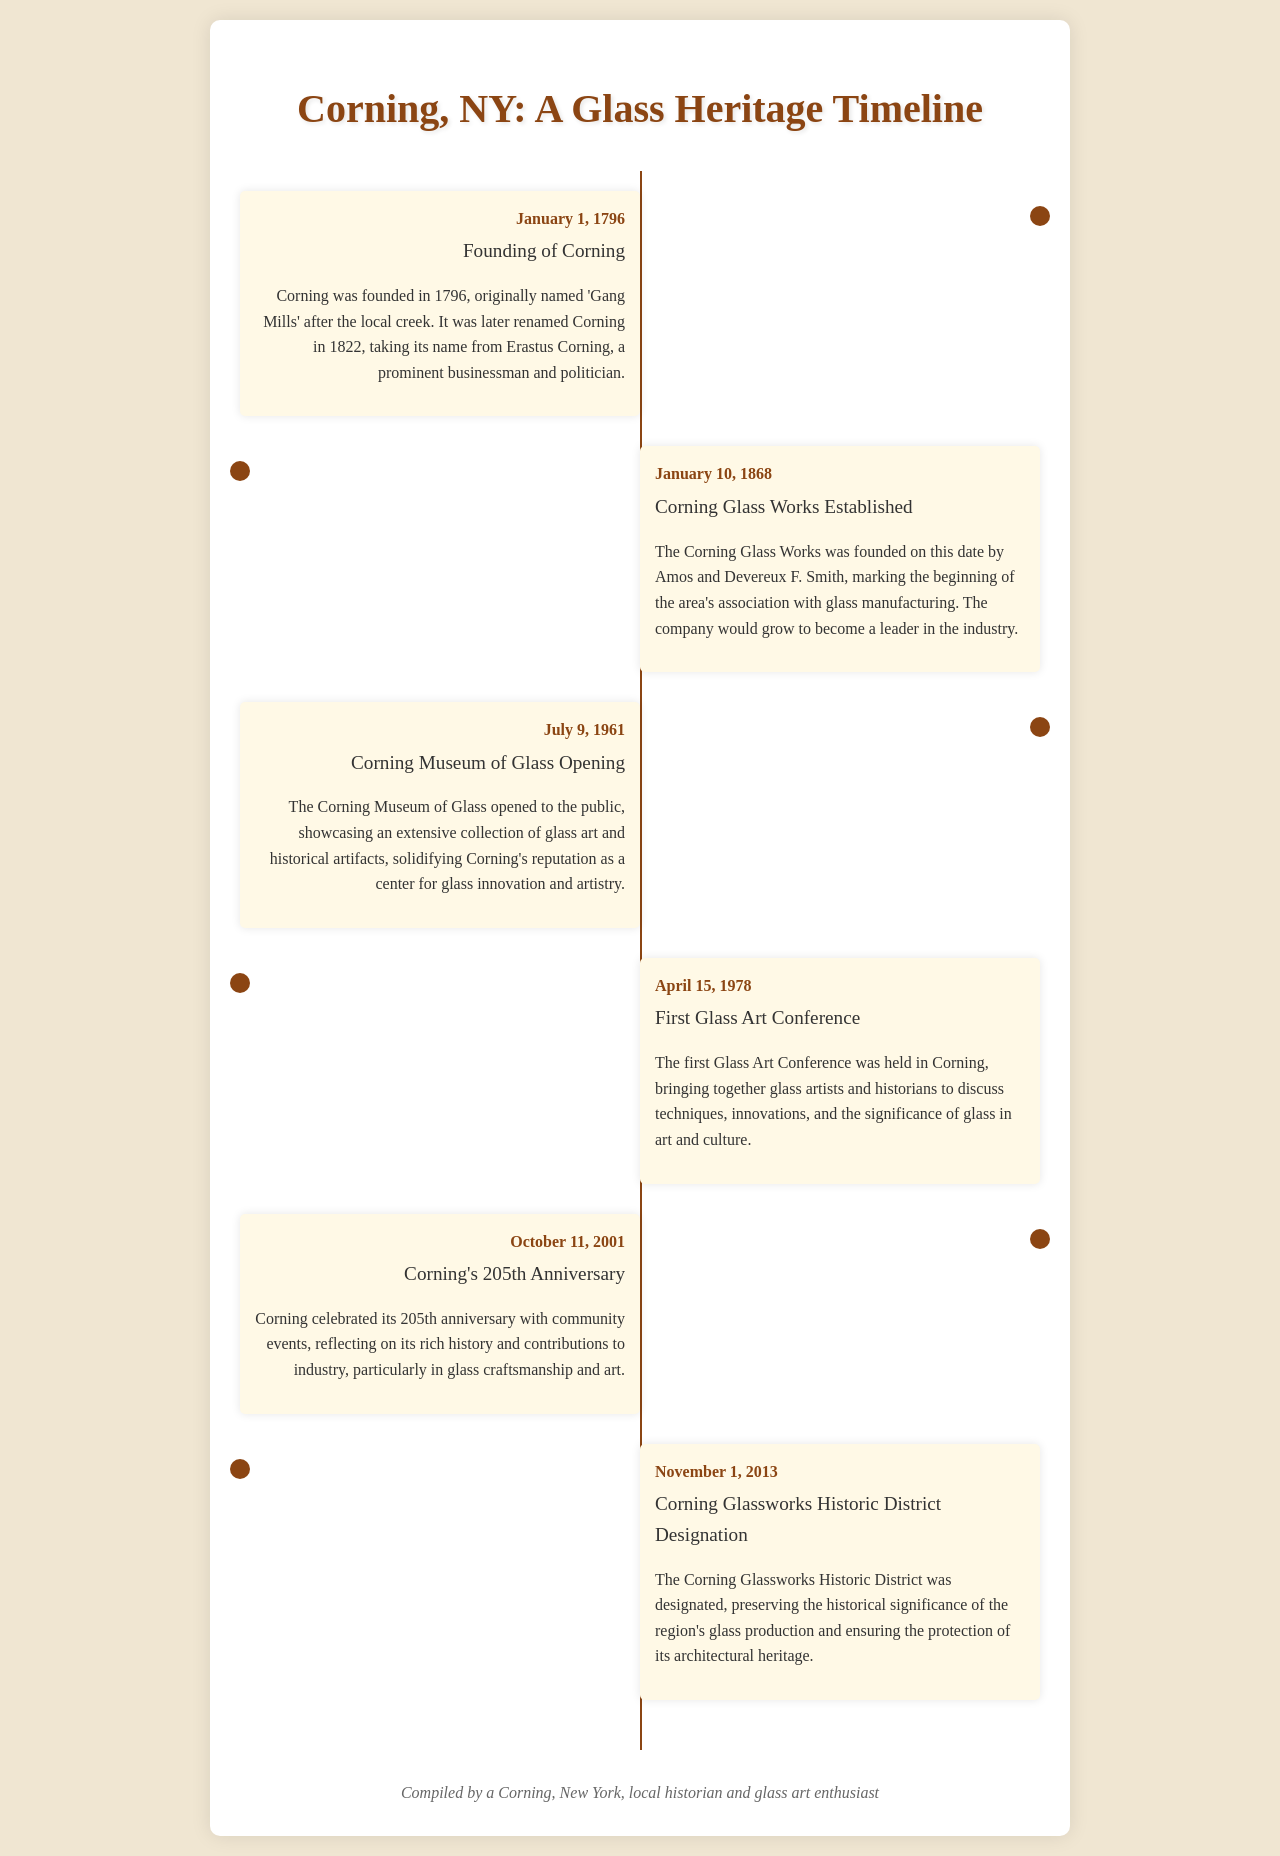What year was Corning founded? The document states that Corning was founded on January 1, 1796.
Answer: 1796 Who established Corning Glass Works? The text mentions that Corning Glass Works was founded by Amos and Devereux F. Smith.
Answer: Amos and Devereux F. Smith When did the Corning Museum of Glass open? According to the document, the Corning Museum of Glass opened on July 9, 1961.
Answer: July 9, 1961 What significant event occurred on April 15, 1978? The document notes that the first Glass Art Conference was held on this date in Corning.
Answer: First Glass Art Conference What anniversary did Corning celebrate on October 11, 2001? The text indicates that Corning celebrated its 205th anniversary on this date.
Answer: 205th anniversary What historic designation was given on November 1, 2013? The document states that the Corning Glassworks Historic District was designated on this date.
Answer: Corning Glassworks Historic District Designation What kind of events reflected on the history of Corning in 2001? The document mentions that community events reflected on Corning's history and contributions to the industry.
Answer: Community events How did Corning's name change from its original? The document describes that it was originally named 'Gang Mills' before being renamed in 1822.
Answer: 'Gang Mills' What is the primary focus of the cultural significance mentioned in the timeline? The timeline emphasizes the significance of glass innovation and artistry in Corning.
Answer: Glass innovation and artistry 